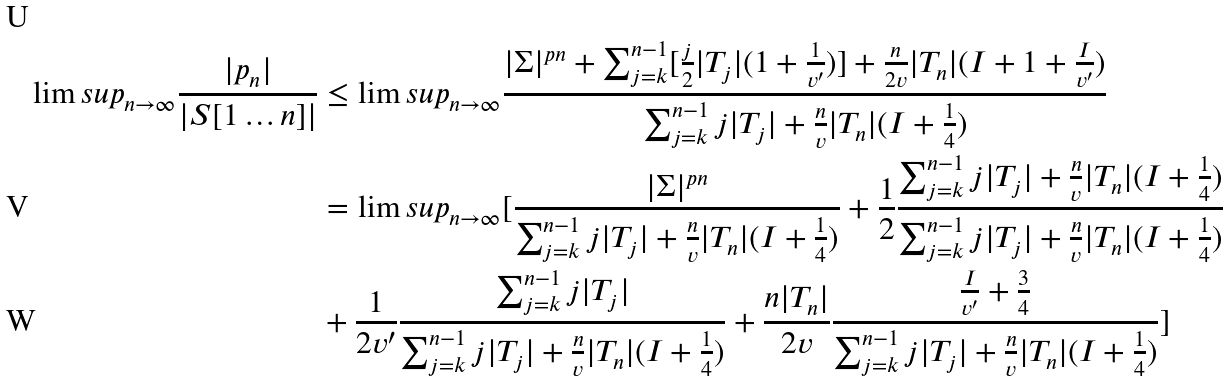<formula> <loc_0><loc_0><loc_500><loc_500>\lim s u p _ { n \rightarrow \infty } \frac { | p _ { n } | } { | S [ 1 \dots n ] | } & \leq \lim s u p _ { n \rightarrow \infty } \frac { | \Sigma | ^ { p n } + \sum _ { j = k } ^ { n - 1 } [ \frac { j } { 2 } | T _ { j } | ( 1 + \frac { 1 } { v ^ { \prime } } ) ] + \frac { n } { 2 v } | T _ { n } | ( I + 1 + \frac { I } { v ^ { \prime } } ) } { \sum _ { j = k } ^ { n - 1 } j | T _ { j } | + \frac { n } { v } | T _ { n } | ( I + \frac { 1 } { 4 } ) } \\ & = \lim s u p _ { n \rightarrow \infty } [ \frac { | \Sigma | ^ { p n } } { \sum _ { j = k } ^ { n - 1 } j | T _ { j } | + \frac { n } { v } | T _ { n } | ( I + \frac { 1 } { 4 } ) } + \frac { 1 } { 2 } \frac { \sum _ { j = k } ^ { n - 1 } j | T _ { j } | + \frac { n } { v } | T _ { n } | ( I + \frac { 1 } { 4 } ) } { \sum _ { j = k } ^ { n - 1 } j | T _ { j } | + \frac { n } { v } | T _ { n } | ( I + \frac { 1 } { 4 } ) } \\ & + \frac { 1 } { 2 v ^ { \prime } } \frac { \sum _ { j = k } ^ { n - 1 } j | T _ { j } | } { \sum _ { j = k } ^ { n - 1 } j | T _ { j } | + \frac { n } { v } | T _ { n } | ( I + \frac { 1 } { 4 } ) } + \frac { n | T _ { n } | } { 2 v } \frac { \frac { I } { v ^ { \prime } } + \frac { 3 } { 4 } } { \sum _ { j = k } ^ { n - 1 } j | T _ { j } | + \frac { n } { v } | T _ { n } | ( I + \frac { 1 } { 4 } ) } ]</formula> 